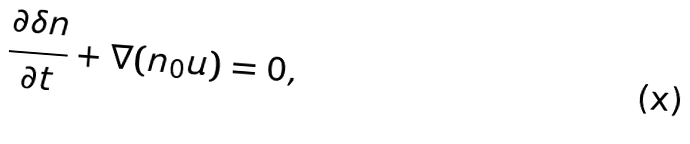Convert formula to latex. <formula><loc_0><loc_0><loc_500><loc_500>\frac { \partial \delta n } { \partial t } + \nabla ( n _ { 0 } { u } ) = 0 ,</formula> 